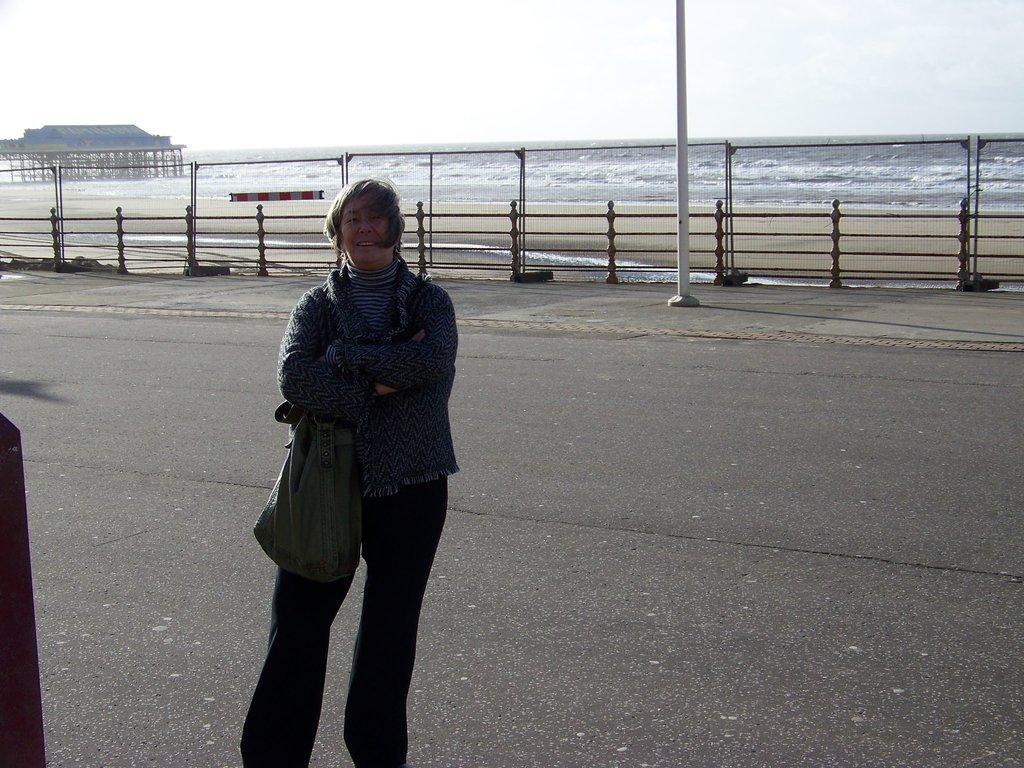Please provide a concise description of this image. A person is standing on the road wearing a bag. There is a fence and water at the back. 